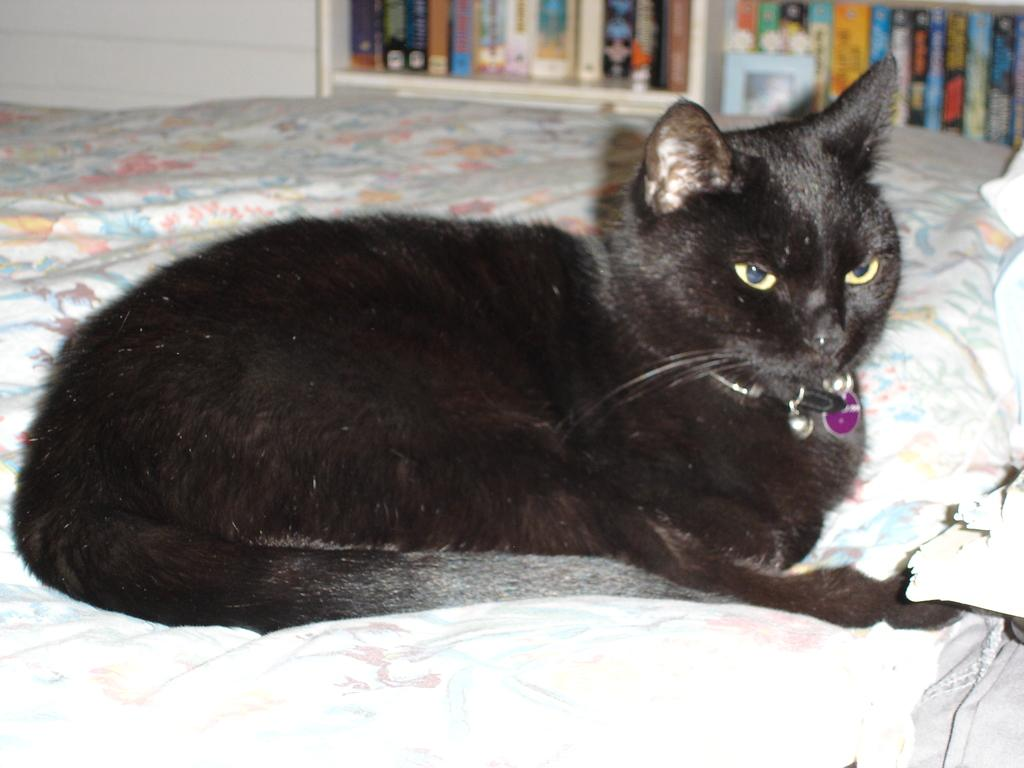What type of animal is in the image? There is a black color cat in the image. Where is the cat located in the image? The cat is lying on the bed. What can be seen in the background of the image? There are shelves in the background of the image. What is on the shelves? The shelves contain books. What is on the right side of the image? There is a pillow on the right side of the image. How does the cat help the family during a quicksand emergency in the image? There is no mention of a family or quicksand emergency in the image; it only features a black color cat lying on a bed with shelves containing books in the background. 